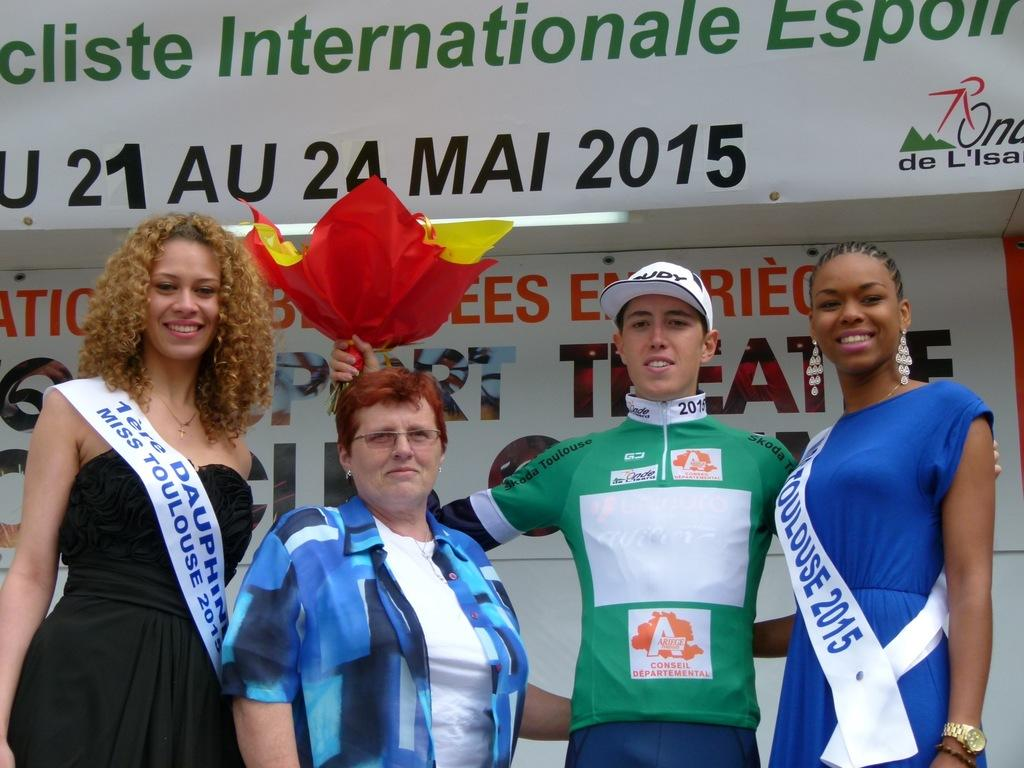What is the main focus of the image? The main focus of the image is the people in the center. Can you describe what one of the people is holding? Yes, a woman is holding a bouquet in her hand. What can be seen in the background of the image? There is a poster in the background area. What type of wine is being served at the event in the image? There is no indication of wine or an event in the image; it primarily features people and a woman holding a bouquet. Can you tell me how much money the cat in the image has earned? There is no cat present in the image, so it is not possible to determine how much money it has earned. 